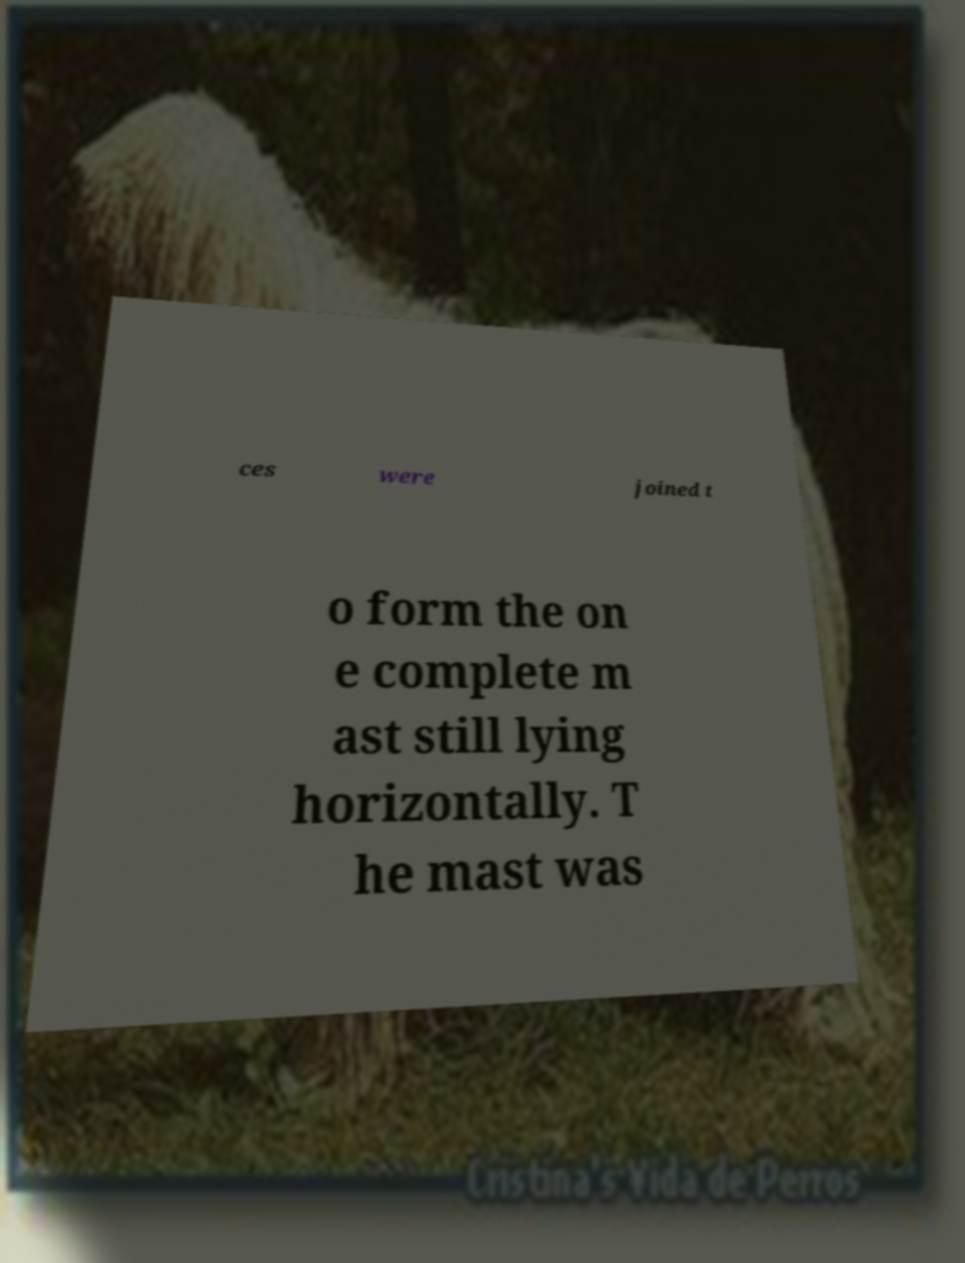Could you extract and type out the text from this image? ces were joined t o form the on e complete m ast still lying horizontally. T he mast was 